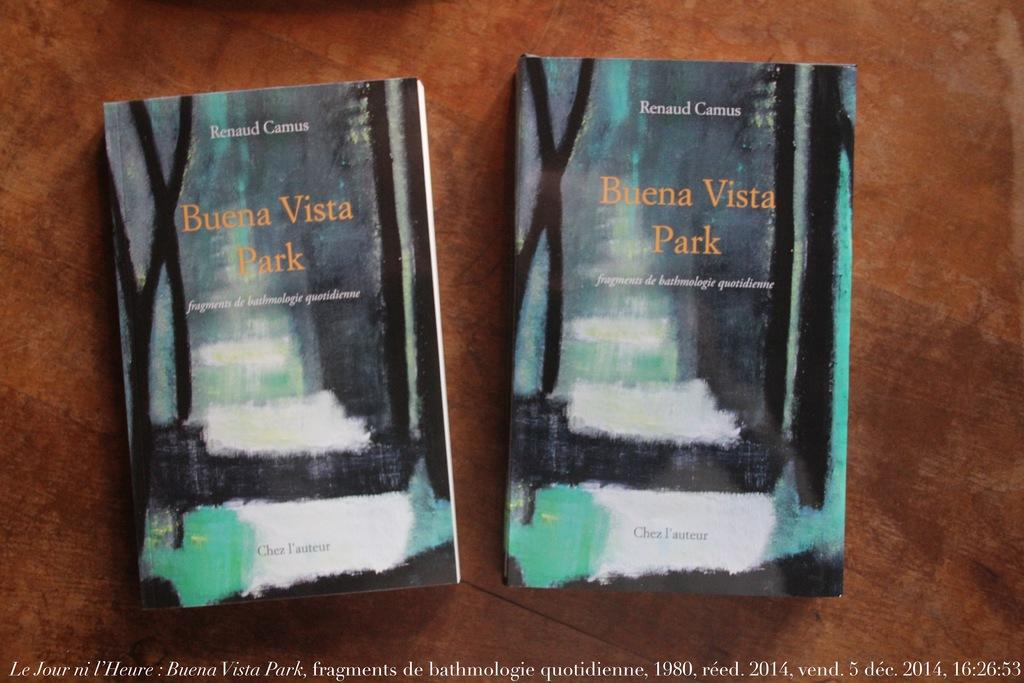<image>
Render a clear and concise summary of the photo. Two copies of Buena Vista Park sitting on a table. 